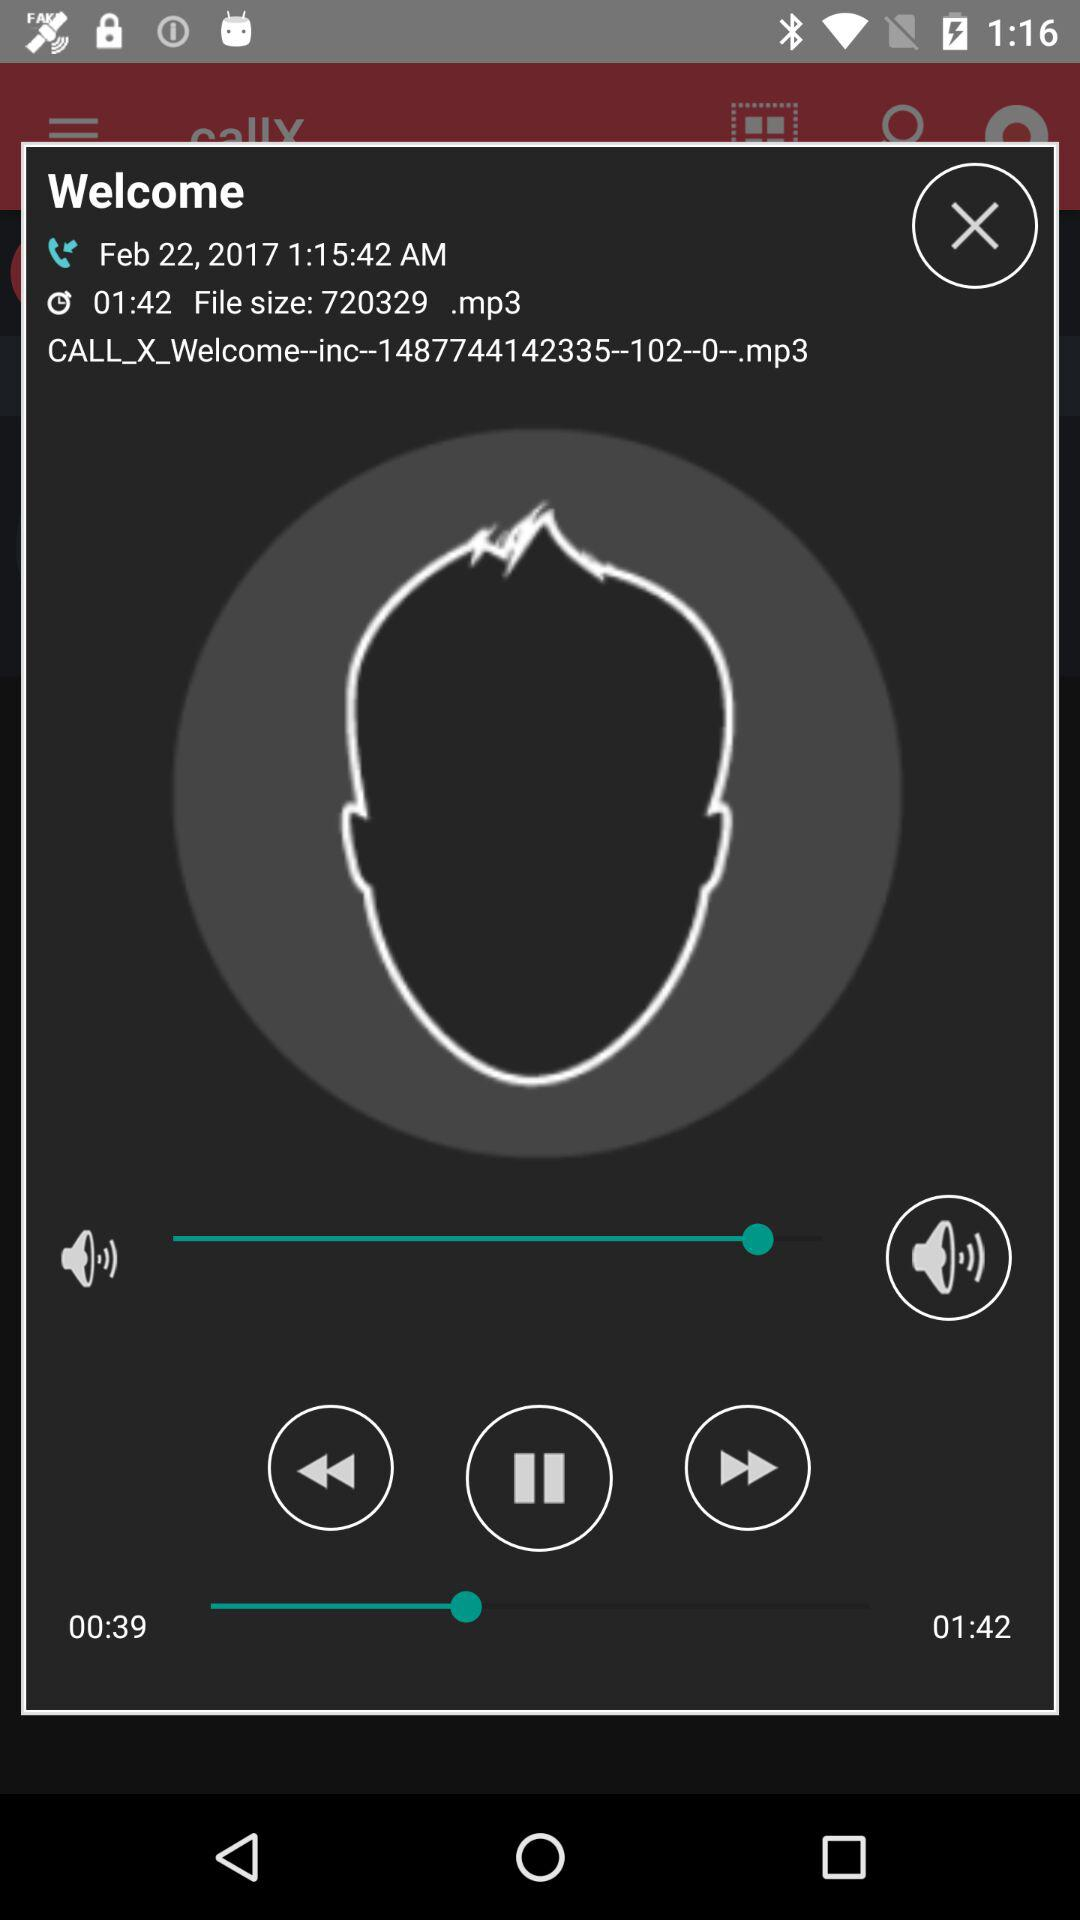What is the name of the audio file?
Answer the question using a single word or phrase. CALL_X_Welcome--inc--1487744142335-102--0-.mp3 